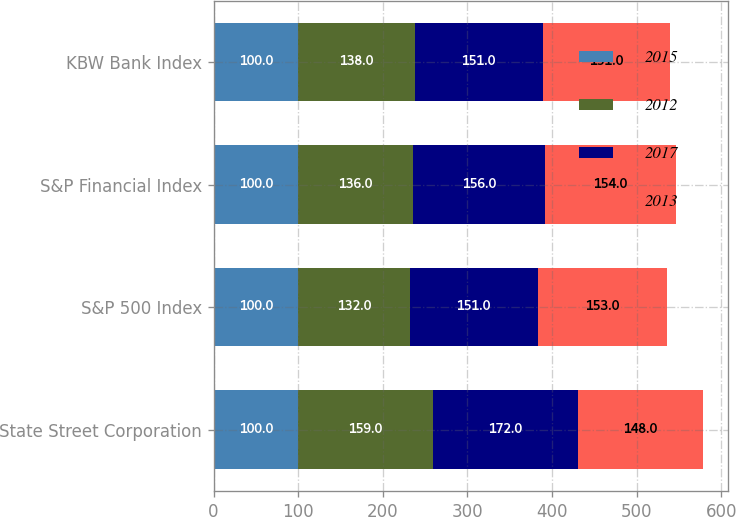<chart> <loc_0><loc_0><loc_500><loc_500><stacked_bar_chart><ecel><fcel>State Street Corporation<fcel>S&P 500 Index<fcel>S&P Financial Index<fcel>KBW Bank Index<nl><fcel>2015<fcel>100<fcel>100<fcel>100<fcel>100<nl><fcel>2012<fcel>159<fcel>132<fcel>136<fcel>138<nl><fcel>2017<fcel>172<fcel>151<fcel>156<fcel>151<nl><fcel>2013<fcel>148<fcel>153<fcel>154<fcel>151<nl></chart> 